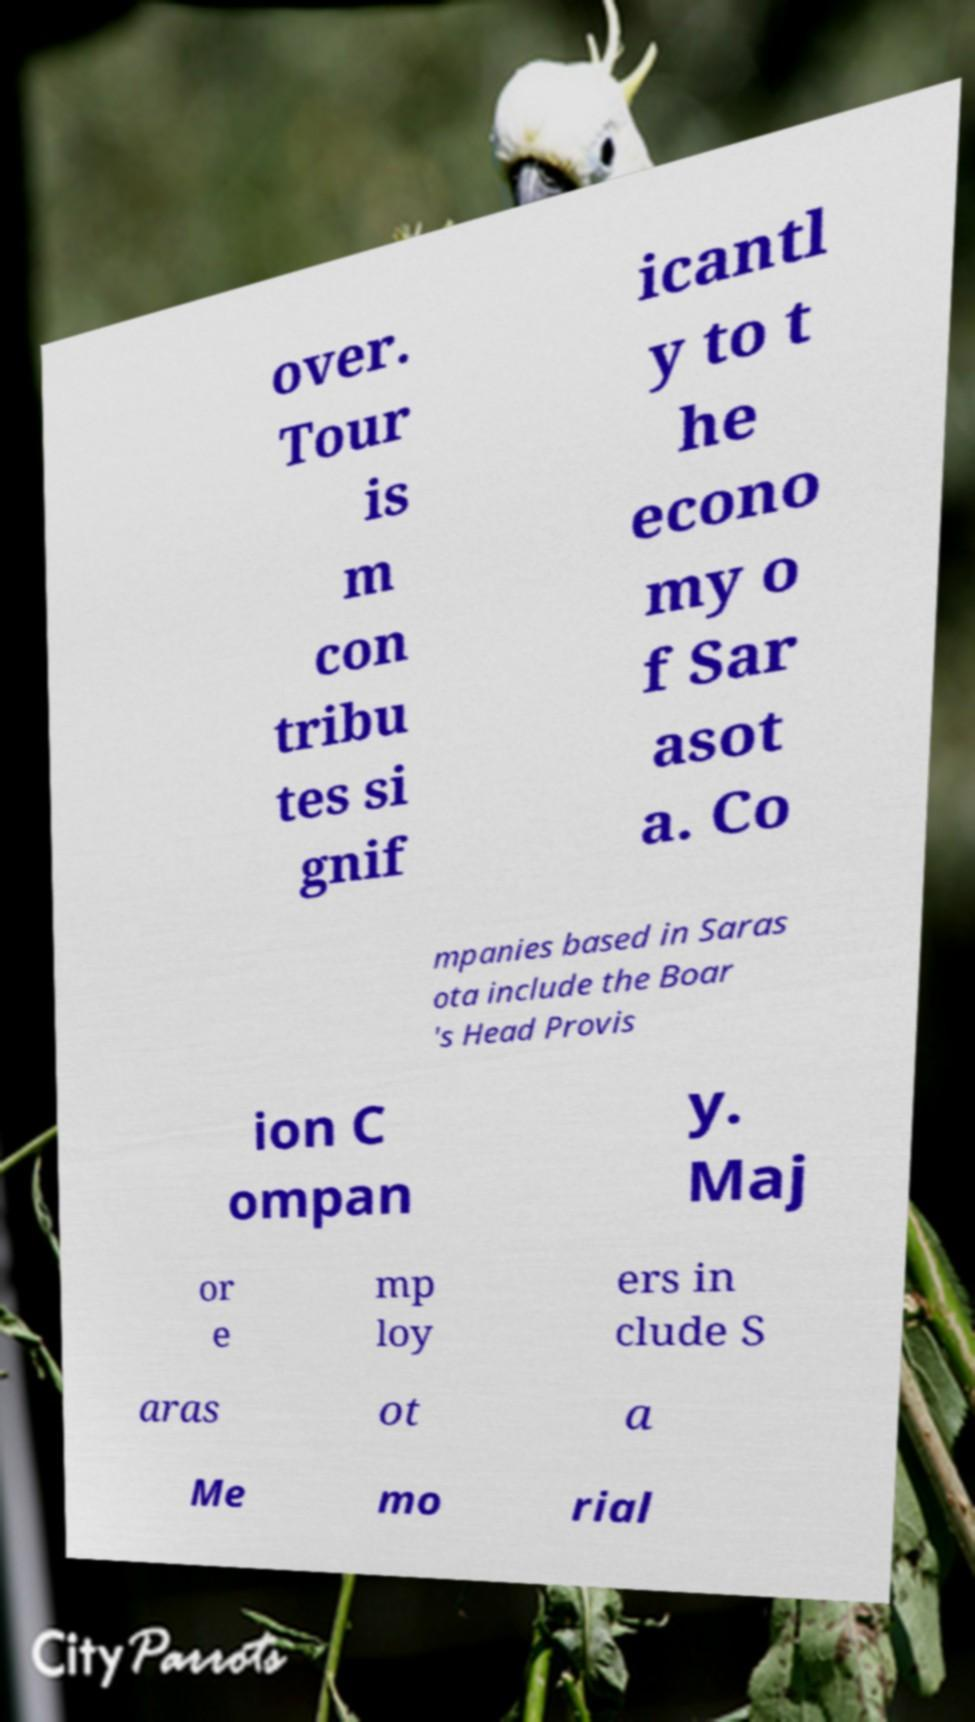Could you extract and type out the text from this image? over. Tour is m con tribu tes si gnif icantl y to t he econo my o f Sar asot a. Co mpanies based in Saras ota include the Boar 's Head Provis ion C ompan y. Maj or e mp loy ers in clude S aras ot a Me mo rial 